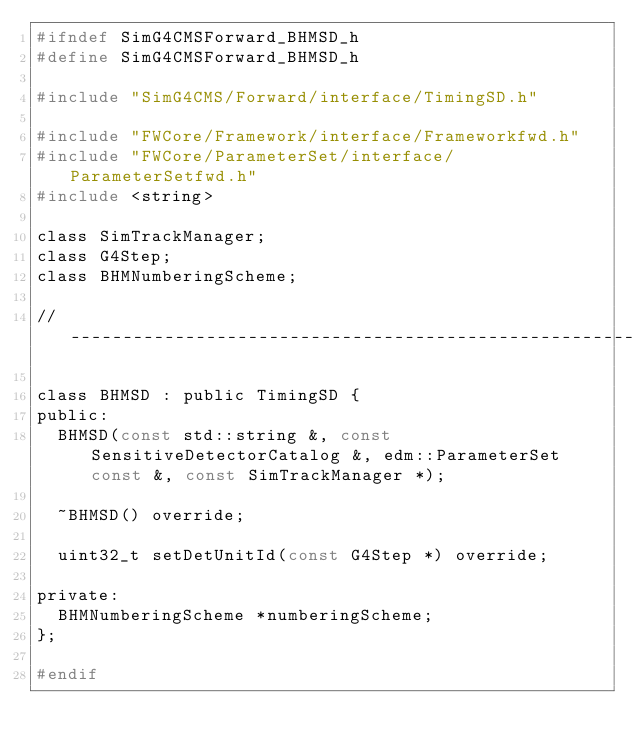Convert code to text. <code><loc_0><loc_0><loc_500><loc_500><_C_>#ifndef SimG4CMSForward_BHMSD_h
#define SimG4CMSForward_BHMSD_h

#include "SimG4CMS/Forward/interface/TimingSD.h"

#include "FWCore/Framework/interface/Frameworkfwd.h"
#include "FWCore/ParameterSet/interface/ParameterSetfwd.h"
#include <string>

class SimTrackManager;
class G4Step;
class BHMNumberingScheme;

//-------------------------------------------------------------------

class BHMSD : public TimingSD {
public:
  BHMSD(const std::string &, const SensitiveDetectorCatalog &, edm::ParameterSet const &, const SimTrackManager *);

  ~BHMSD() override;

  uint32_t setDetUnitId(const G4Step *) override;

private:
  BHMNumberingScheme *numberingScheme;
};

#endif
</code> 